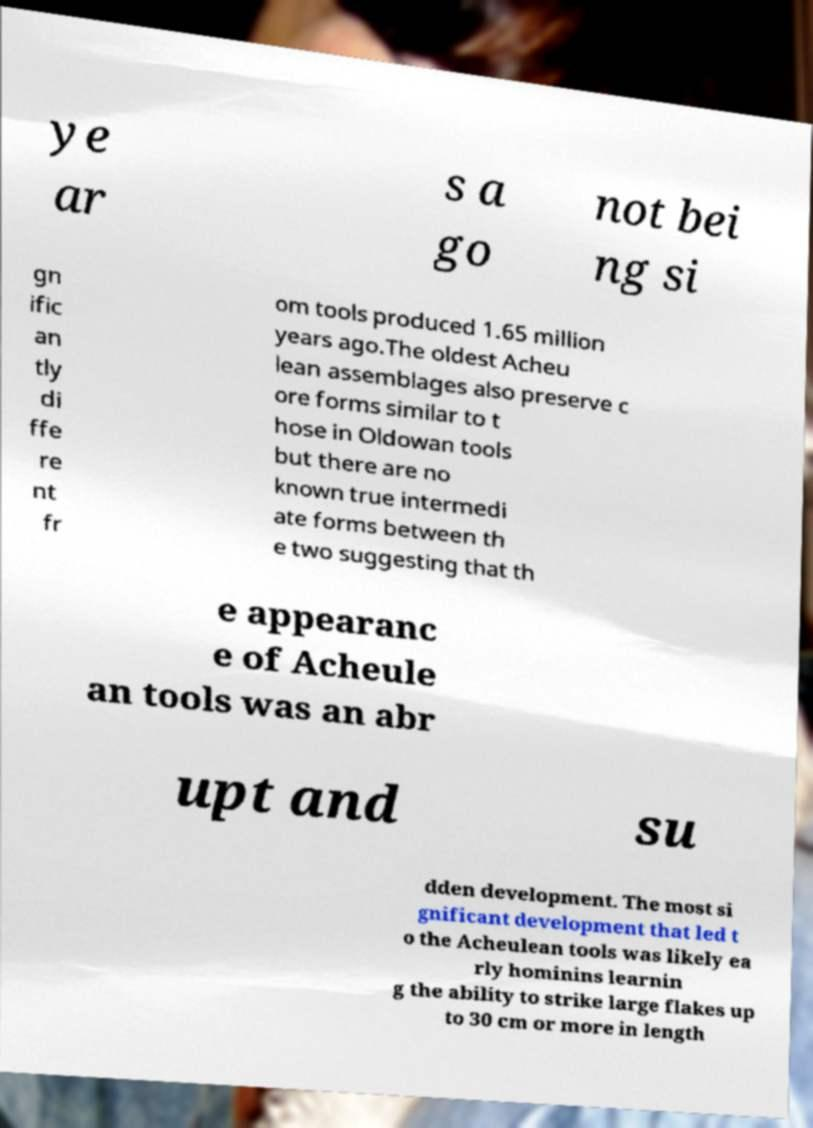What messages or text are displayed in this image? I need them in a readable, typed format. ye ar s a go not bei ng si gn ific an tly di ffe re nt fr om tools produced 1.65 million years ago.The oldest Acheu lean assemblages also preserve c ore forms similar to t hose in Oldowan tools but there are no known true intermedi ate forms between th e two suggesting that th e appearanc e of Acheule an tools was an abr upt and su dden development. The most si gnificant development that led t o the Acheulean tools was likely ea rly hominins learnin g the ability to strike large flakes up to 30 cm or more in length 